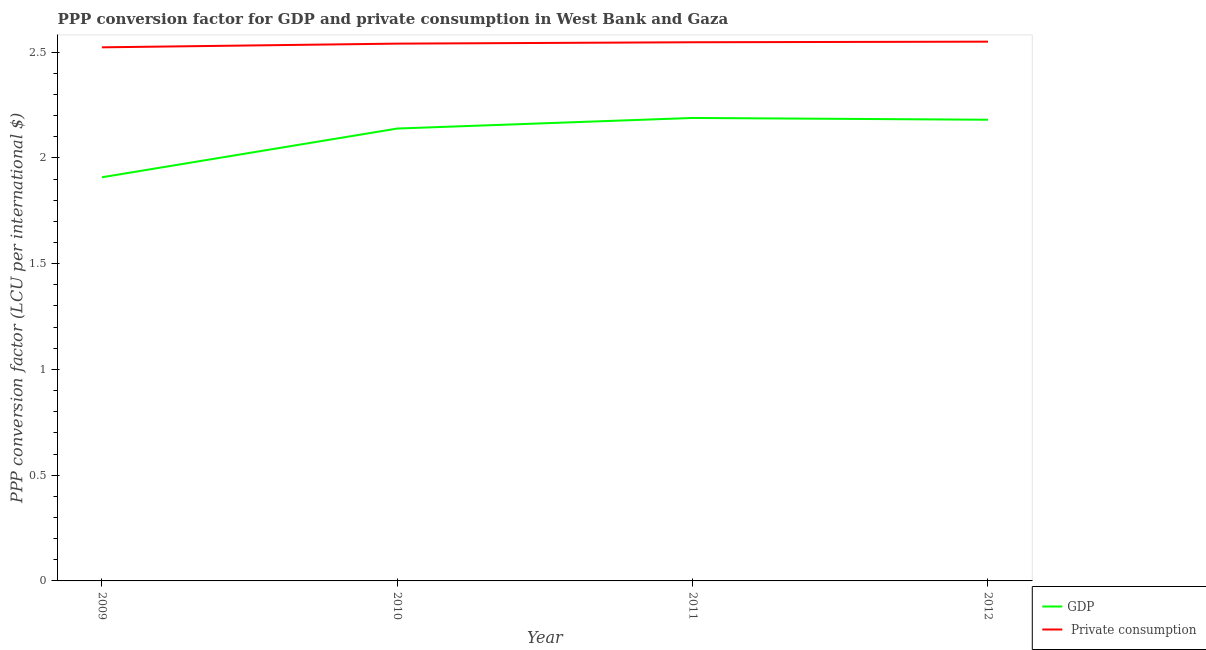How many different coloured lines are there?
Make the answer very short. 2. Does the line corresponding to ppp conversion factor for private consumption intersect with the line corresponding to ppp conversion factor for gdp?
Keep it short and to the point. No. What is the ppp conversion factor for gdp in 2009?
Offer a very short reply. 1.91. Across all years, what is the maximum ppp conversion factor for gdp?
Offer a terse response. 2.19. Across all years, what is the minimum ppp conversion factor for gdp?
Ensure brevity in your answer.  1.91. In which year was the ppp conversion factor for private consumption maximum?
Provide a succinct answer. 2012. In which year was the ppp conversion factor for private consumption minimum?
Your response must be concise. 2009. What is the total ppp conversion factor for gdp in the graph?
Your answer should be very brief. 8.42. What is the difference between the ppp conversion factor for gdp in 2009 and that in 2011?
Offer a very short reply. -0.28. What is the difference between the ppp conversion factor for gdp in 2010 and the ppp conversion factor for private consumption in 2009?
Ensure brevity in your answer.  -0.38. What is the average ppp conversion factor for gdp per year?
Your response must be concise. 2.1. In the year 2011, what is the difference between the ppp conversion factor for gdp and ppp conversion factor for private consumption?
Offer a terse response. -0.36. What is the ratio of the ppp conversion factor for private consumption in 2009 to that in 2010?
Offer a very short reply. 0.99. Is the ppp conversion factor for private consumption in 2009 less than that in 2011?
Make the answer very short. Yes. What is the difference between the highest and the second highest ppp conversion factor for gdp?
Your answer should be compact. 0.01. What is the difference between the highest and the lowest ppp conversion factor for gdp?
Provide a short and direct response. 0.28. Is the sum of the ppp conversion factor for private consumption in 2011 and 2012 greater than the maximum ppp conversion factor for gdp across all years?
Your answer should be compact. Yes. Is the ppp conversion factor for gdp strictly greater than the ppp conversion factor for private consumption over the years?
Your answer should be compact. No. How many lines are there?
Offer a very short reply. 2. What is the difference between two consecutive major ticks on the Y-axis?
Give a very brief answer. 0.5. Are the values on the major ticks of Y-axis written in scientific E-notation?
Provide a succinct answer. No. Does the graph contain any zero values?
Provide a succinct answer. No. How many legend labels are there?
Ensure brevity in your answer.  2. What is the title of the graph?
Your response must be concise. PPP conversion factor for GDP and private consumption in West Bank and Gaza. Does "Under-5(male)" appear as one of the legend labels in the graph?
Ensure brevity in your answer.  No. What is the label or title of the X-axis?
Make the answer very short. Year. What is the label or title of the Y-axis?
Keep it short and to the point. PPP conversion factor (LCU per international $). What is the PPP conversion factor (LCU per international $) of GDP in 2009?
Make the answer very short. 1.91. What is the PPP conversion factor (LCU per international $) of  Private consumption in 2009?
Provide a short and direct response. 2.52. What is the PPP conversion factor (LCU per international $) in GDP in 2010?
Your response must be concise. 2.14. What is the PPP conversion factor (LCU per international $) in  Private consumption in 2010?
Offer a terse response. 2.54. What is the PPP conversion factor (LCU per international $) in GDP in 2011?
Offer a very short reply. 2.19. What is the PPP conversion factor (LCU per international $) of  Private consumption in 2011?
Provide a succinct answer. 2.55. What is the PPP conversion factor (LCU per international $) in GDP in 2012?
Ensure brevity in your answer.  2.18. What is the PPP conversion factor (LCU per international $) of  Private consumption in 2012?
Offer a very short reply. 2.55. Across all years, what is the maximum PPP conversion factor (LCU per international $) in GDP?
Your answer should be compact. 2.19. Across all years, what is the maximum PPP conversion factor (LCU per international $) of  Private consumption?
Provide a short and direct response. 2.55. Across all years, what is the minimum PPP conversion factor (LCU per international $) of GDP?
Make the answer very short. 1.91. Across all years, what is the minimum PPP conversion factor (LCU per international $) in  Private consumption?
Your response must be concise. 2.52. What is the total PPP conversion factor (LCU per international $) of GDP in the graph?
Keep it short and to the point. 8.42. What is the total PPP conversion factor (LCU per international $) of  Private consumption in the graph?
Your answer should be very brief. 10.16. What is the difference between the PPP conversion factor (LCU per international $) of GDP in 2009 and that in 2010?
Offer a very short reply. -0.23. What is the difference between the PPP conversion factor (LCU per international $) of  Private consumption in 2009 and that in 2010?
Your answer should be very brief. -0.02. What is the difference between the PPP conversion factor (LCU per international $) in GDP in 2009 and that in 2011?
Offer a terse response. -0.28. What is the difference between the PPP conversion factor (LCU per international $) of  Private consumption in 2009 and that in 2011?
Give a very brief answer. -0.02. What is the difference between the PPP conversion factor (LCU per international $) of GDP in 2009 and that in 2012?
Provide a succinct answer. -0.27. What is the difference between the PPP conversion factor (LCU per international $) in  Private consumption in 2009 and that in 2012?
Provide a short and direct response. -0.03. What is the difference between the PPP conversion factor (LCU per international $) in GDP in 2010 and that in 2011?
Your answer should be very brief. -0.05. What is the difference between the PPP conversion factor (LCU per international $) of  Private consumption in 2010 and that in 2011?
Give a very brief answer. -0.01. What is the difference between the PPP conversion factor (LCU per international $) in GDP in 2010 and that in 2012?
Offer a very short reply. -0.04. What is the difference between the PPP conversion factor (LCU per international $) in  Private consumption in 2010 and that in 2012?
Your answer should be compact. -0.01. What is the difference between the PPP conversion factor (LCU per international $) of GDP in 2011 and that in 2012?
Provide a succinct answer. 0.01. What is the difference between the PPP conversion factor (LCU per international $) in  Private consumption in 2011 and that in 2012?
Ensure brevity in your answer.  -0. What is the difference between the PPP conversion factor (LCU per international $) of GDP in 2009 and the PPP conversion factor (LCU per international $) of  Private consumption in 2010?
Your answer should be compact. -0.63. What is the difference between the PPP conversion factor (LCU per international $) in GDP in 2009 and the PPP conversion factor (LCU per international $) in  Private consumption in 2011?
Your answer should be compact. -0.64. What is the difference between the PPP conversion factor (LCU per international $) in GDP in 2009 and the PPP conversion factor (LCU per international $) in  Private consumption in 2012?
Give a very brief answer. -0.64. What is the difference between the PPP conversion factor (LCU per international $) in GDP in 2010 and the PPP conversion factor (LCU per international $) in  Private consumption in 2011?
Give a very brief answer. -0.41. What is the difference between the PPP conversion factor (LCU per international $) in GDP in 2010 and the PPP conversion factor (LCU per international $) in  Private consumption in 2012?
Provide a short and direct response. -0.41. What is the difference between the PPP conversion factor (LCU per international $) in GDP in 2011 and the PPP conversion factor (LCU per international $) in  Private consumption in 2012?
Provide a short and direct response. -0.36. What is the average PPP conversion factor (LCU per international $) of GDP per year?
Your answer should be very brief. 2.1. What is the average PPP conversion factor (LCU per international $) of  Private consumption per year?
Ensure brevity in your answer.  2.54. In the year 2009, what is the difference between the PPP conversion factor (LCU per international $) in GDP and PPP conversion factor (LCU per international $) in  Private consumption?
Make the answer very short. -0.61. In the year 2010, what is the difference between the PPP conversion factor (LCU per international $) of GDP and PPP conversion factor (LCU per international $) of  Private consumption?
Offer a terse response. -0.4. In the year 2011, what is the difference between the PPP conversion factor (LCU per international $) of GDP and PPP conversion factor (LCU per international $) of  Private consumption?
Your response must be concise. -0.36. In the year 2012, what is the difference between the PPP conversion factor (LCU per international $) in GDP and PPP conversion factor (LCU per international $) in  Private consumption?
Offer a terse response. -0.37. What is the ratio of the PPP conversion factor (LCU per international $) in GDP in 2009 to that in 2010?
Provide a succinct answer. 0.89. What is the ratio of the PPP conversion factor (LCU per international $) in  Private consumption in 2009 to that in 2010?
Provide a succinct answer. 0.99. What is the ratio of the PPP conversion factor (LCU per international $) of GDP in 2009 to that in 2011?
Provide a short and direct response. 0.87. What is the ratio of the PPP conversion factor (LCU per international $) in  Private consumption in 2009 to that in 2011?
Keep it short and to the point. 0.99. What is the ratio of the PPP conversion factor (LCU per international $) of GDP in 2009 to that in 2012?
Offer a terse response. 0.88. What is the ratio of the PPP conversion factor (LCU per international $) in GDP in 2010 to that in 2011?
Provide a short and direct response. 0.98. What is the ratio of the PPP conversion factor (LCU per international $) of  Private consumption in 2010 to that in 2011?
Ensure brevity in your answer.  1. What is the ratio of the PPP conversion factor (LCU per international $) in GDP in 2010 to that in 2012?
Your answer should be very brief. 0.98. What is the ratio of the PPP conversion factor (LCU per international $) in  Private consumption in 2010 to that in 2012?
Make the answer very short. 1. What is the difference between the highest and the second highest PPP conversion factor (LCU per international $) of GDP?
Your answer should be compact. 0.01. What is the difference between the highest and the second highest PPP conversion factor (LCU per international $) in  Private consumption?
Offer a very short reply. 0. What is the difference between the highest and the lowest PPP conversion factor (LCU per international $) in GDP?
Provide a succinct answer. 0.28. What is the difference between the highest and the lowest PPP conversion factor (LCU per international $) in  Private consumption?
Your response must be concise. 0.03. 